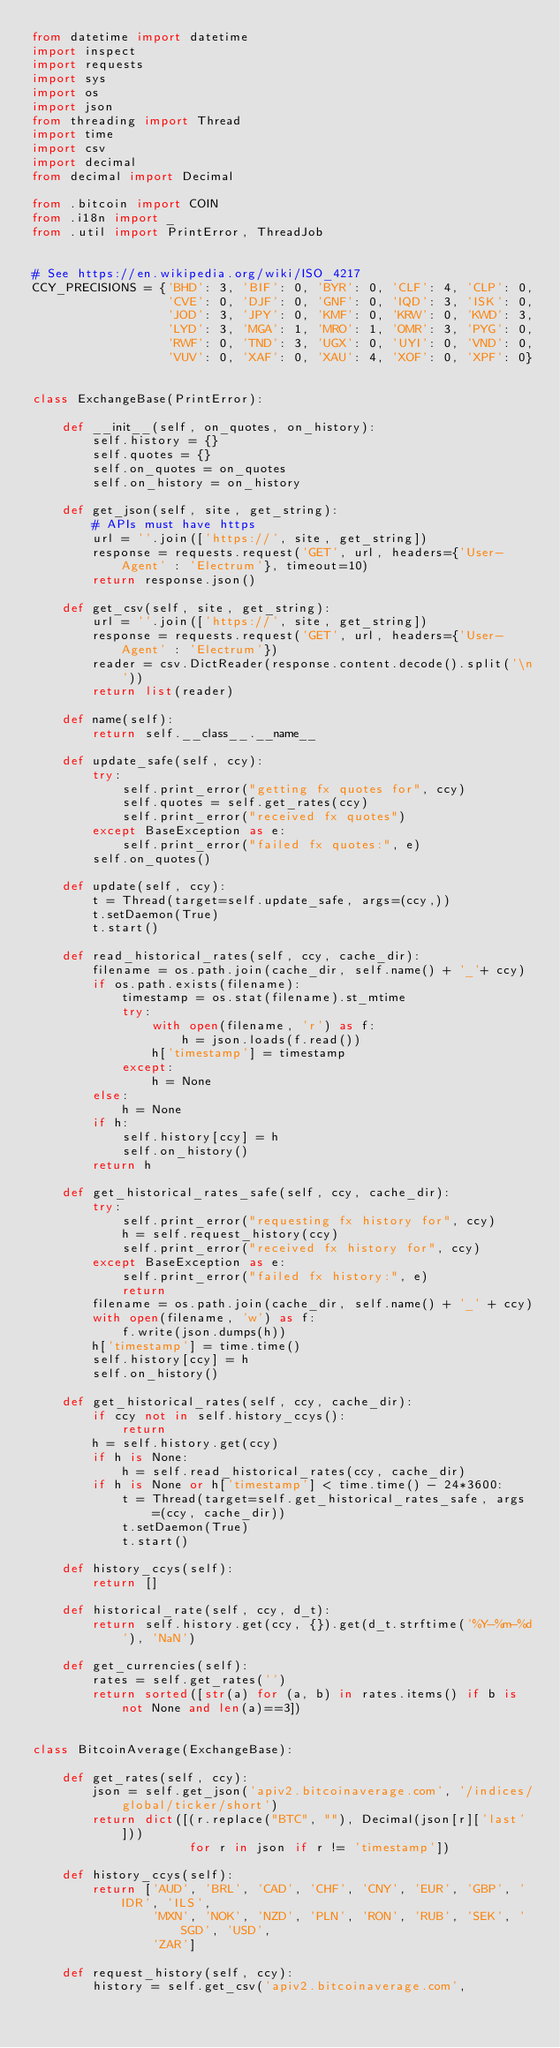Convert code to text. <code><loc_0><loc_0><loc_500><loc_500><_Python_>from datetime import datetime
import inspect
import requests
import sys
import os
import json
from threading import Thread
import time
import csv
import decimal
from decimal import Decimal

from .bitcoin import COIN
from .i18n import _
from .util import PrintError, ThreadJob


# See https://en.wikipedia.org/wiki/ISO_4217
CCY_PRECISIONS = {'BHD': 3, 'BIF': 0, 'BYR': 0, 'CLF': 4, 'CLP': 0,
                  'CVE': 0, 'DJF': 0, 'GNF': 0, 'IQD': 3, 'ISK': 0,
                  'JOD': 3, 'JPY': 0, 'KMF': 0, 'KRW': 0, 'KWD': 3,
                  'LYD': 3, 'MGA': 1, 'MRO': 1, 'OMR': 3, 'PYG': 0,
                  'RWF': 0, 'TND': 3, 'UGX': 0, 'UYI': 0, 'VND': 0,
                  'VUV': 0, 'XAF': 0, 'XAU': 4, 'XOF': 0, 'XPF': 0}


class ExchangeBase(PrintError):

    def __init__(self, on_quotes, on_history):
        self.history = {}
        self.quotes = {}
        self.on_quotes = on_quotes
        self.on_history = on_history

    def get_json(self, site, get_string):
        # APIs must have https
        url = ''.join(['https://', site, get_string])
        response = requests.request('GET', url, headers={'User-Agent' : 'Electrum'}, timeout=10)
        return response.json()

    def get_csv(self, site, get_string):
        url = ''.join(['https://', site, get_string])
        response = requests.request('GET', url, headers={'User-Agent' : 'Electrum'})
        reader = csv.DictReader(response.content.decode().split('\n'))
        return list(reader)

    def name(self):
        return self.__class__.__name__

    def update_safe(self, ccy):
        try:
            self.print_error("getting fx quotes for", ccy)
            self.quotes = self.get_rates(ccy)
            self.print_error("received fx quotes")
        except BaseException as e:
            self.print_error("failed fx quotes:", e)
        self.on_quotes()

    def update(self, ccy):
        t = Thread(target=self.update_safe, args=(ccy,))
        t.setDaemon(True)
        t.start()

    def read_historical_rates(self, ccy, cache_dir):
        filename = os.path.join(cache_dir, self.name() + '_'+ ccy)
        if os.path.exists(filename):
            timestamp = os.stat(filename).st_mtime
            try:
                with open(filename, 'r') as f:
                    h = json.loads(f.read())
                h['timestamp'] = timestamp
            except:
                h = None
        else:
            h = None
        if h:
            self.history[ccy] = h
            self.on_history()
        return h

    def get_historical_rates_safe(self, ccy, cache_dir):
        try:
            self.print_error("requesting fx history for", ccy)
            h = self.request_history(ccy)
            self.print_error("received fx history for", ccy)
        except BaseException as e:
            self.print_error("failed fx history:", e)
            return
        filename = os.path.join(cache_dir, self.name() + '_' + ccy)
        with open(filename, 'w') as f:
            f.write(json.dumps(h))
        h['timestamp'] = time.time()
        self.history[ccy] = h
        self.on_history()

    def get_historical_rates(self, ccy, cache_dir):
        if ccy not in self.history_ccys():
            return
        h = self.history.get(ccy)
        if h is None:
            h = self.read_historical_rates(ccy, cache_dir)
        if h is None or h['timestamp'] < time.time() - 24*3600:
            t = Thread(target=self.get_historical_rates_safe, args=(ccy, cache_dir))
            t.setDaemon(True)
            t.start()

    def history_ccys(self):
        return []

    def historical_rate(self, ccy, d_t):
        return self.history.get(ccy, {}).get(d_t.strftime('%Y-%m-%d'), 'NaN')

    def get_currencies(self):
        rates = self.get_rates('')
        return sorted([str(a) for (a, b) in rates.items() if b is not None and len(a)==3])


class BitcoinAverage(ExchangeBase):

    def get_rates(self, ccy):
        json = self.get_json('apiv2.bitcoinaverage.com', '/indices/global/ticker/short')
        return dict([(r.replace("BTC", ""), Decimal(json[r]['last']))
                     for r in json if r != 'timestamp'])

    def history_ccys(self):
        return ['AUD', 'BRL', 'CAD', 'CHF', 'CNY', 'EUR', 'GBP', 'IDR', 'ILS',
                'MXN', 'NOK', 'NZD', 'PLN', 'RON', 'RUB', 'SEK', 'SGD', 'USD',
                'ZAR']

    def request_history(self, ccy):
        history = self.get_csv('apiv2.bitcoinaverage.com',</code> 